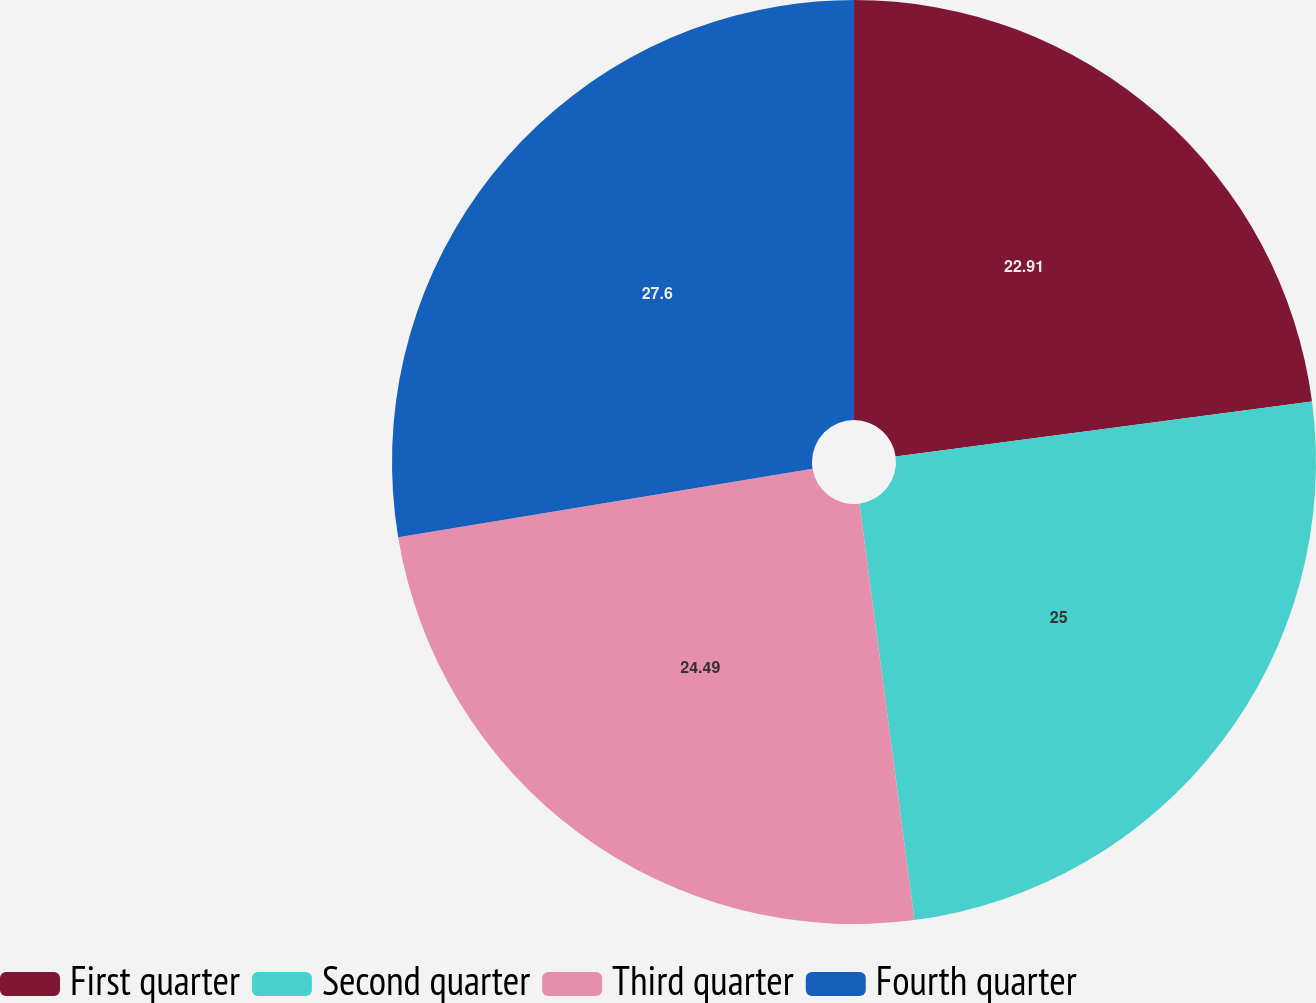Convert chart to OTSL. <chart><loc_0><loc_0><loc_500><loc_500><pie_chart><fcel>First quarter<fcel>Second quarter<fcel>Third quarter<fcel>Fourth quarter<nl><fcel>22.91%<fcel>25.0%<fcel>24.49%<fcel>27.6%<nl></chart> 